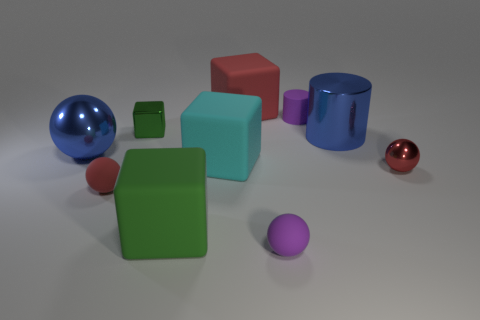Do the blue metal cylinder and the blue ball have the same size?
Ensure brevity in your answer.  Yes. What number of objects are matte blocks in front of the small metallic ball or big shiny things to the right of the shiny block?
Offer a terse response. 2. What material is the tiny purple thing behind the metallic cylinder to the right of the cyan thing?
Ensure brevity in your answer.  Rubber. What number of other things are the same material as the purple cylinder?
Give a very brief answer. 5. Is the tiny red metal thing the same shape as the large cyan matte thing?
Your answer should be compact. No. What size is the blue shiny object to the left of the metal cylinder?
Make the answer very short. Large. Does the red matte ball have the same size as the blue shiny thing to the left of the green shiny block?
Ensure brevity in your answer.  No. Are there fewer green metal cubes that are right of the large cyan rubber object than tiny green shiny blocks?
Ensure brevity in your answer.  Yes. There is a small green thing that is the same shape as the big cyan matte thing; what is it made of?
Provide a succinct answer. Metal. There is a red thing that is both in front of the purple cylinder and left of the large blue cylinder; what is its shape?
Your response must be concise. Sphere. 